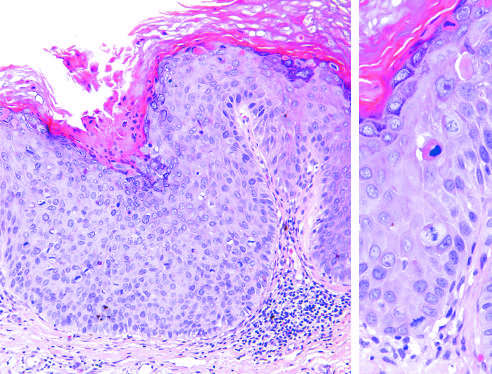what does higher magnification show?
Answer the question using a single word or phrase. Several mitotic figures 